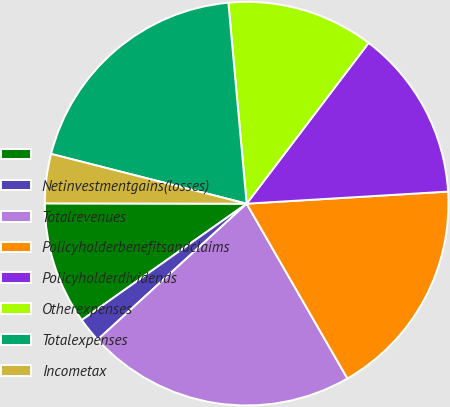<chart> <loc_0><loc_0><loc_500><loc_500><pie_chart><ecel><fcel>Netinvestmentgains(losses)<fcel>Totalrevenues<fcel>Policyholderbenefitsandclaims<fcel>Policyholderdividends<fcel>Otherexpenses<fcel>Totalexpenses<fcel>Incometax<nl><fcel>9.81%<fcel>1.99%<fcel>21.55%<fcel>17.63%<fcel>13.72%<fcel>11.77%<fcel>19.59%<fcel>3.94%<nl></chart> 